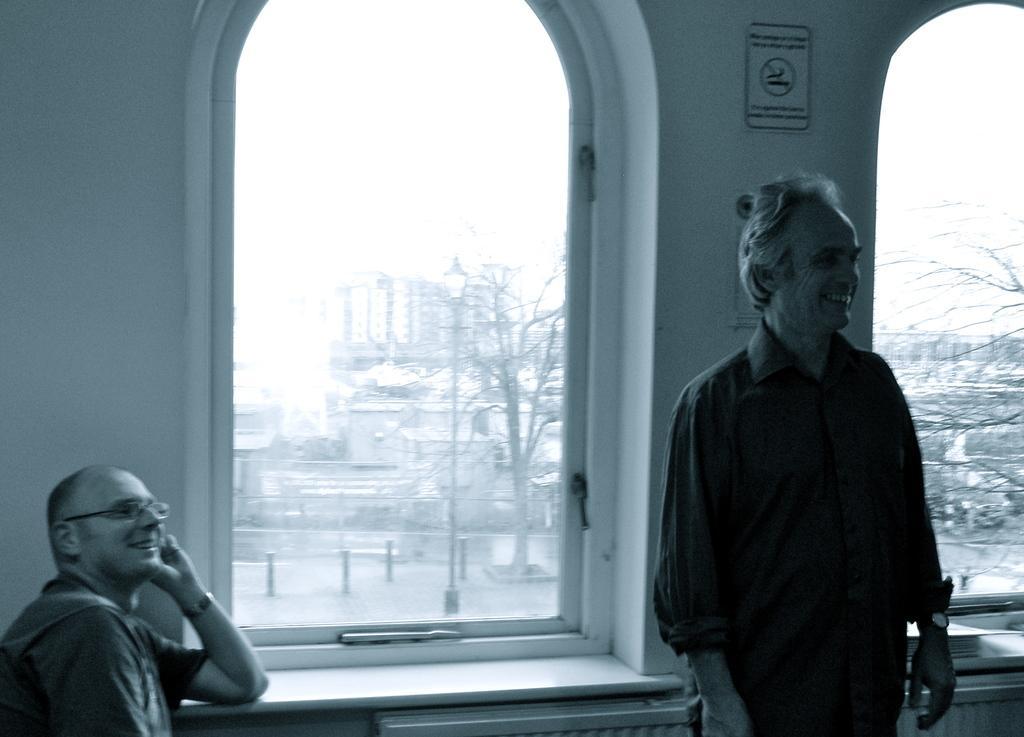Describe this image in one or two sentences. In this image I can see there is a man sitting to the left side and there is another man standing on the right side and there is a wall behind them, there are two windows and there are a building and trees visible from the window and the sky is clear. 